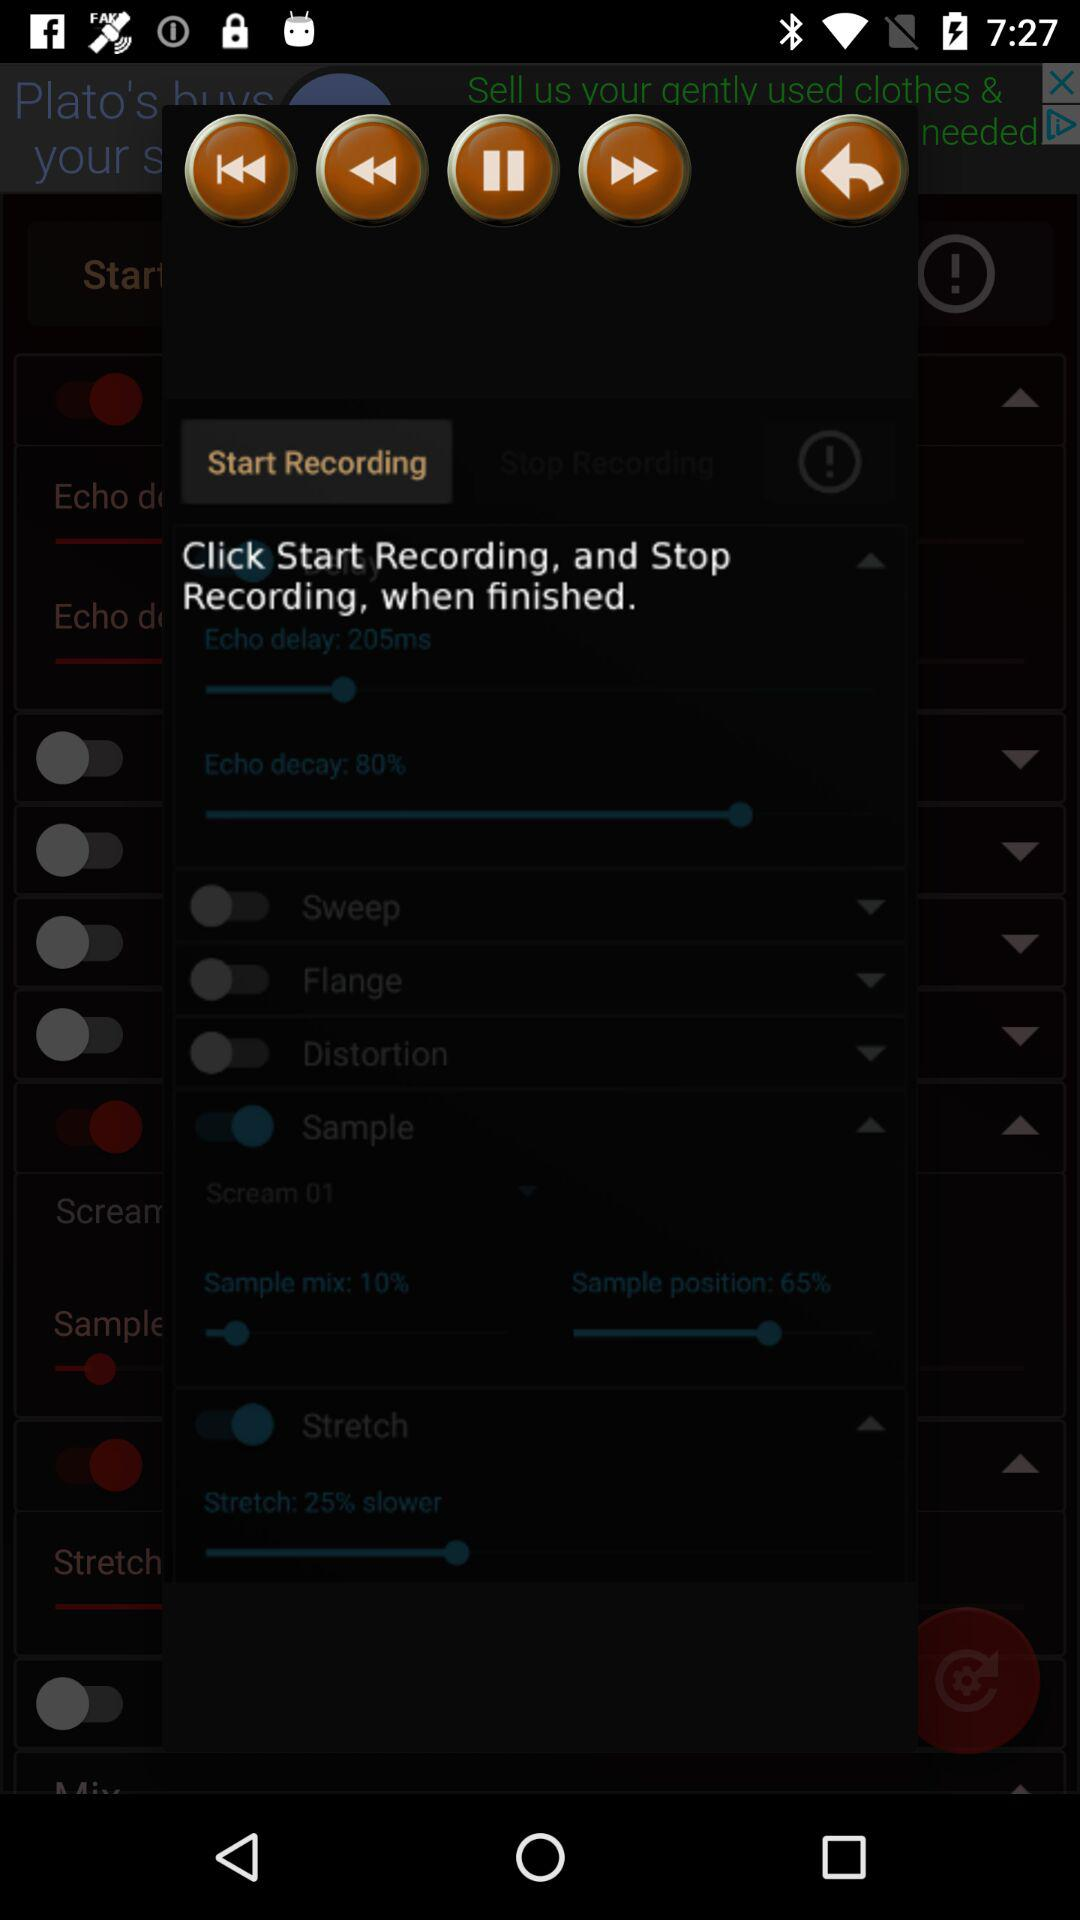What is the percentage of "Echo decay"? The percentage of "Echo decay" is 80. 